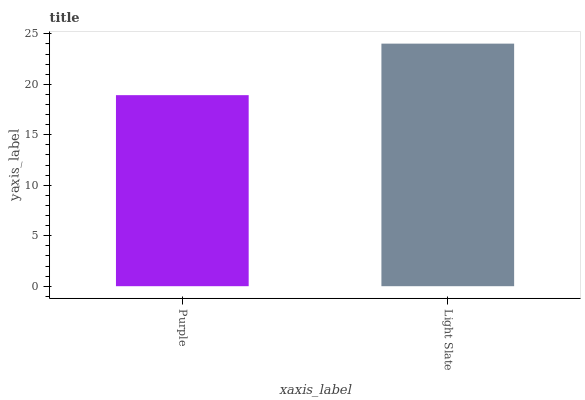Is Purple the minimum?
Answer yes or no. Yes. Is Light Slate the maximum?
Answer yes or no. Yes. Is Light Slate the minimum?
Answer yes or no. No. Is Light Slate greater than Purple?
Answer yes or no. Yes. Is Purple less than Light Slate?
Answer yes or no. Yes. Is Purple greater than Light Slate?
Answer yes or no. No. Is Light Slate less than Purple?
Answer yes or no. No. Is Light Slate the high median?
Answer yes or no. Yes. Is Purple the low median?
Answer yes or no. Yes. Is Purple the high median?
Answer yes or no. No. Is Light Slate the low median?
Answer yes or no. No. 